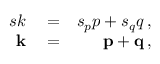<formula> <loc_0><loc_0><loc_500><loc_500>\begin{array} { r l r } { s k } & = } & { s _ { p } p + s _ { q } q \, , } \\ { k } & = } & { { p } + { q } \, , } \end{array}</formula> 